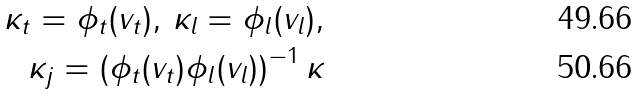Convert formula to latex. <formula><loc_0><loc_0><loc_500><loc_500>\kappa _ { t } = \phi _ { t } ( v _ { t } ) , \, \kappa _ { l } = \phi _ { l } ( v _ { l } ) , \\ \kappa _ { j } = \left ( \phi _ { t } ( v _ { t } ) \phi _ { l } ( v _ { l } ) \right ) ^ { - 1 } \kappa</formula> 